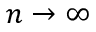Convert formula to latex. <formula><loc_0><loc_0><loc_500><loc_500>n \to \infty</formula> 